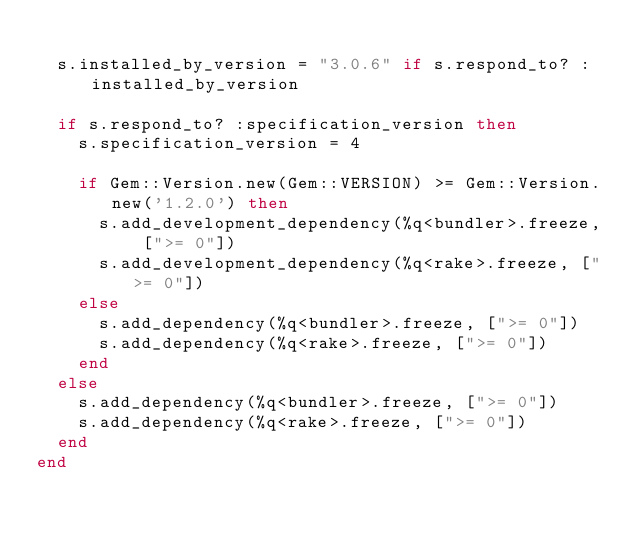<code> <loc_0><loc_0><loc_500><loc_500><_Ruby_>
  s.installed_by_version = "3.0.6" if s.respond_to? :installed_by_version

  if s.respond_to? :specification_version then
    s.specification_version = 4

    if Gem::Version.new(Gem::VERSION) >= Gem::Version.new('1.2.0') then
      s.add_development_dependency(%q<bundler>.freeze, [">= 0"])
      s.add_development_dependency(%q<rake>.freeze, [">= 0"])
    else
      s.add_dependency(%q<bundler>.freeze, [">= 0"])
      s.add_dependency(%q<rake>.freeze, [">= 0"])
    end
  else
    s.add_dependency(%q<bundler>.freeze, [">= 0"])
    s.add_dependency(%q<rake>.freeze, [">= 0"])
  end
end
</code> 